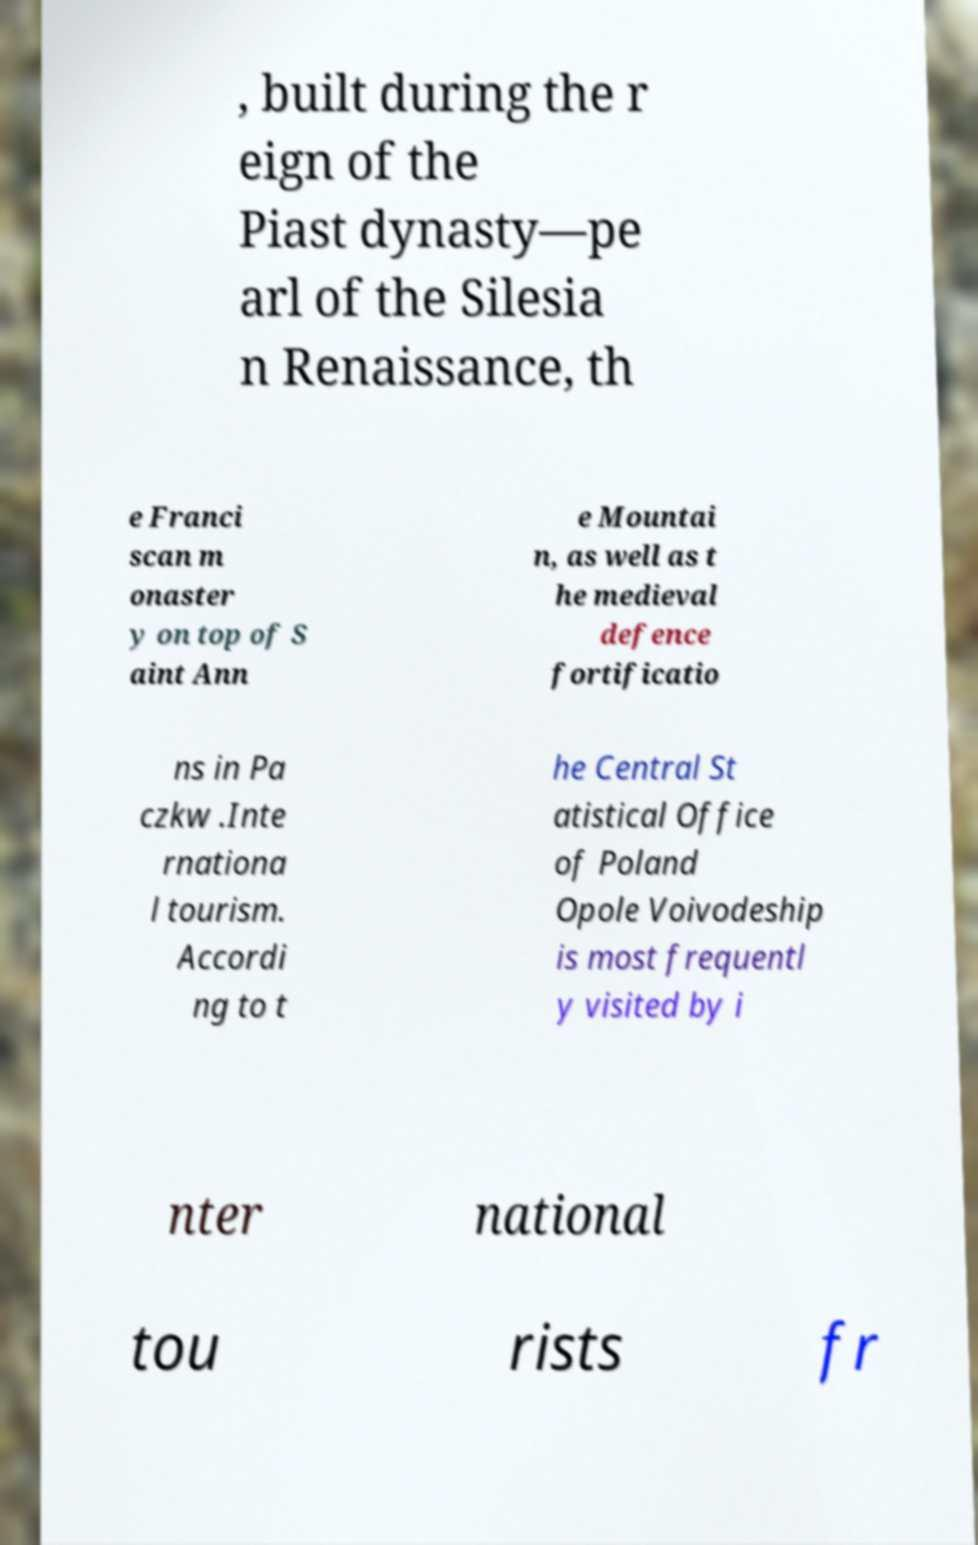Could you extract and type out the text from this image? , built during the r eign of the Piast dynasty—pe arl of the Silesia n Renaissance, th e Franci scan m onaster y on top of S aint Ann e Mountai n, as well as t he medieval defence fortificatio ns in Pa czkw .Inte rnationa l tourism. Accordi ng to t he Central St atistical Office of Poland Opole Voivodeship is most frequentl y visited by i nter national tou rists fr 